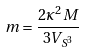<formula> <loc_0><loc_0><loc_500><loc_500>m = \frac { 2 \kappa ^ { 2 } M } { 3 V _ { S ^ { 3 } } }</formula> 